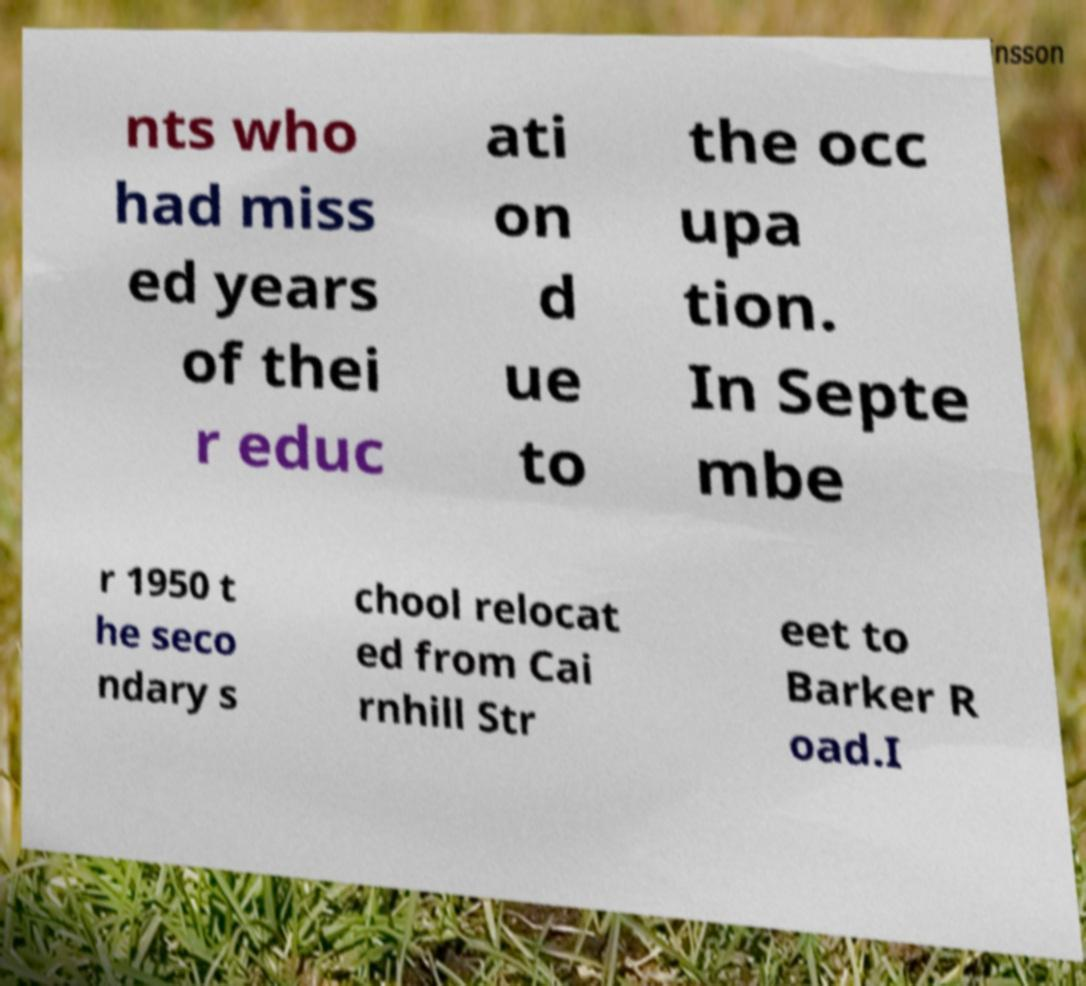Please read and relay the text visible in this image. What does it say? nts who had miss ed years of thei r educ ati on d ue to the occ upa tion. In Septe mbe r 1950 t he seco ndary s chool relocat ed from Cai rnhill Str eet to Barker R oad.I 